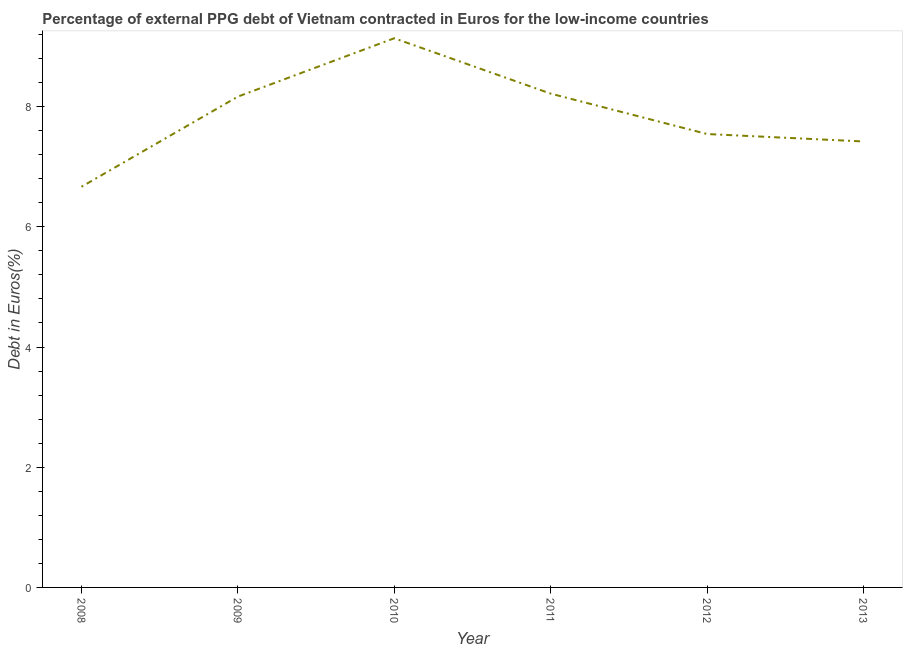What is the currency composition of ppg debt in 2009?
Offer a terse response. 8.17. Across all years, what is the maximum currency composition of ppg debt?
Your response must be concise. 9.14. Across all years, what is the minimum currency composition of ppg debt?
Offer a very short reply. 6.67. What is the sum of the currency composition of ppg debt?
Your response must be concise. 47.15. What is the difference between the currency composition of ppg debt in 2008 and 2011?
Your response must be concise. -1.55. What is the average currency composition of ppg debt per year?
Keep it short and to the point. 7.86. What is the median currency composition of ppg debt?
Give a very brief answer. 7.85. In how many years, is the currency composition of ppg debt greater than 4.8 %?
Your answer should be very brief. 6. What is the ratio of the currency composition of ppg debt in 2008 to that in 2013?
Your response must be concise. 0.9. Is the currency composition of ppg debt in 2008 less than that in 2011?
Make the answer very short. Yes. Is the difference between the currency composition of ppg debt in 2009 and 2011 greater than the difference between any two years?
Your answer should be compact. No. What is the difference between the highest and the second highest currency composition of ppg debt?
Keep it short and to the point. 0.92. Is the sum of the currency composition of ppg debt in 2012 and 2013 greater than the maximum currency composition of ppg debt across all years?
Offer a terse response. Yes. What is the difference between the highest and the lowest currency composition of ppg debt?
Ensure brevity in your answer.  2.47. In how many years, is the currency composition of ppg debt greater than the average currency composition of ppg debt taken over all years?
Give a very brief answer. 3. Does the currency composition of ppg debt monotonically increase over the years?
Offer a terse response. No. Are the values on the major ticks of Y-axis written in scientific E-notation?
Provide a short and direct response. No. What is the title of the graph?
Ensure brevity in your answer.  Percentage of external PPG debt of Vietnam contracted in Euros for the low-income countries. What is the label or title of the X-axis?
Offer a very short reply. Year. What is the label or title of the Y-axis?
Your response must be concise. Debt in Euros(%). What is the Debt in Euros(%) in 2008?
Give a very brief answer. 6.67. What is the Debt in Euros(%) in 2009?
Offer a very short reply. 8.17. What is the Debt in Euros(%) in 2010?
Keep it short and to the point. 9.14. What is the Debt in Euros(%) in 2011?
Offer a very short reply. 8.22. What is the Debt in Euros(%) in 2012?
Ensure brevity in your answer.  7.54. What is the Debt in Euros(%) of 2013?
Offer a terse response. 7.42. What is the difference between the Debt in Euros(%) in 2008 and 2009?
Provide a short and direct response. -1.5. What is the difference between the Debt in Euros(%) in 2008 and 2010?
Your response must be concise. -2.47. What is the difference between the Debt in Euros(%) in 2008 and 2011?
Provide a succinct answer. -1.55. What is the difference between the Debt in Euros(%) in 2008 and 2012?
Keep it short and to the point. -0.88. What is the difference between the Debt in Euros(%) in 2008 and 2013?
Keep it short and to the point. -0.75. What is the difference between the Debt in Euros(%) in 2009 and 2010?
Provide a short and direct response. -0.97. What is the difference between the Debt in Euros(%) in 2009 and 2011?
Make the answer very short. -0.05. What is the difference between the Debt in Euros(%) in 2009 and 2012?
Your answer should be very brief. 0.62. What is the difference between the Debt in Euros(%) in 2009 and 2013?
Your answer should be very brief. 0.75. What is the difference between the Debt in Euros(%) in 2010 and 2011?
Your answer should be compact. 0.92. What is the difference between the Debt in Euros(%) in 2010 and 2012?
Your answer should be compact. 1.59. What is the difference between the Debt in Euros(%) in 2010 and 2013?
Provide a succinct answer. 1.72. What is the difference between the Debt in Euros(%) in 2011 and 2012?
Provide a succinct answer. 0.67. What is the difference between the Debt in Euros(%) in 2011 and 2013?
Provide a short and direct response. 0.8. What is the difference between the Debt in Euros(%) in 2012 and 2013?
Your answer should be compact. 0.12. What is the ratio of the Debt in Euros(%) in 2008 to that in 2009?
Ensure brevity in your answer.  0.82. What is the ratio of the Debt in Euros(%) in 2008 to that in 2010?
Your answer should be very brief. 0.73. What is the ratio of the Debt in Euros(%) in 2008 to that in 2011?
Give a very brief answer. 0.81. What is the ratio of the Debt in Euros(%) in 2008 to that in 2012?
Your answer should be very brief. 0.88. What is the ratio of the Debt in Euros(%) in 2008 to that in 2013?
Offer a terse response. 0.9. What is the ratio of the Debt in Euros(%) in 2009 to that in 2010?
Your answer should be very brief. 0.89. What is the ratio of the Debt in Euros(%) in 2009 to that in 2012?
Give a very brief answer. 1.08. What is the ratio of the Debt in Euros(%) in 2009 to that in 2013?
Your answer should be compact. 1.1. What is the ratio of the Debt in Euros(%) in 2010 to that in 2011?
Make the answer very short. 1.11. What is the ratio of the Debt in Euros(%) in 2010 to that in 2012?
Provide a succinct answer. 1.21. What is the ratio of the Debt in Euros(%) in 2010 to that in 2013?
Your answer should be compact. 1.23. What is the ratio of the Debt in Euros(%) in 2011 to that in 2012?
Provide a short and direct response. 1.09. What is the ratio of the Debt in Euros(%) in 2011 to that in 2013?
Your answer should be very brief. 1.11. 